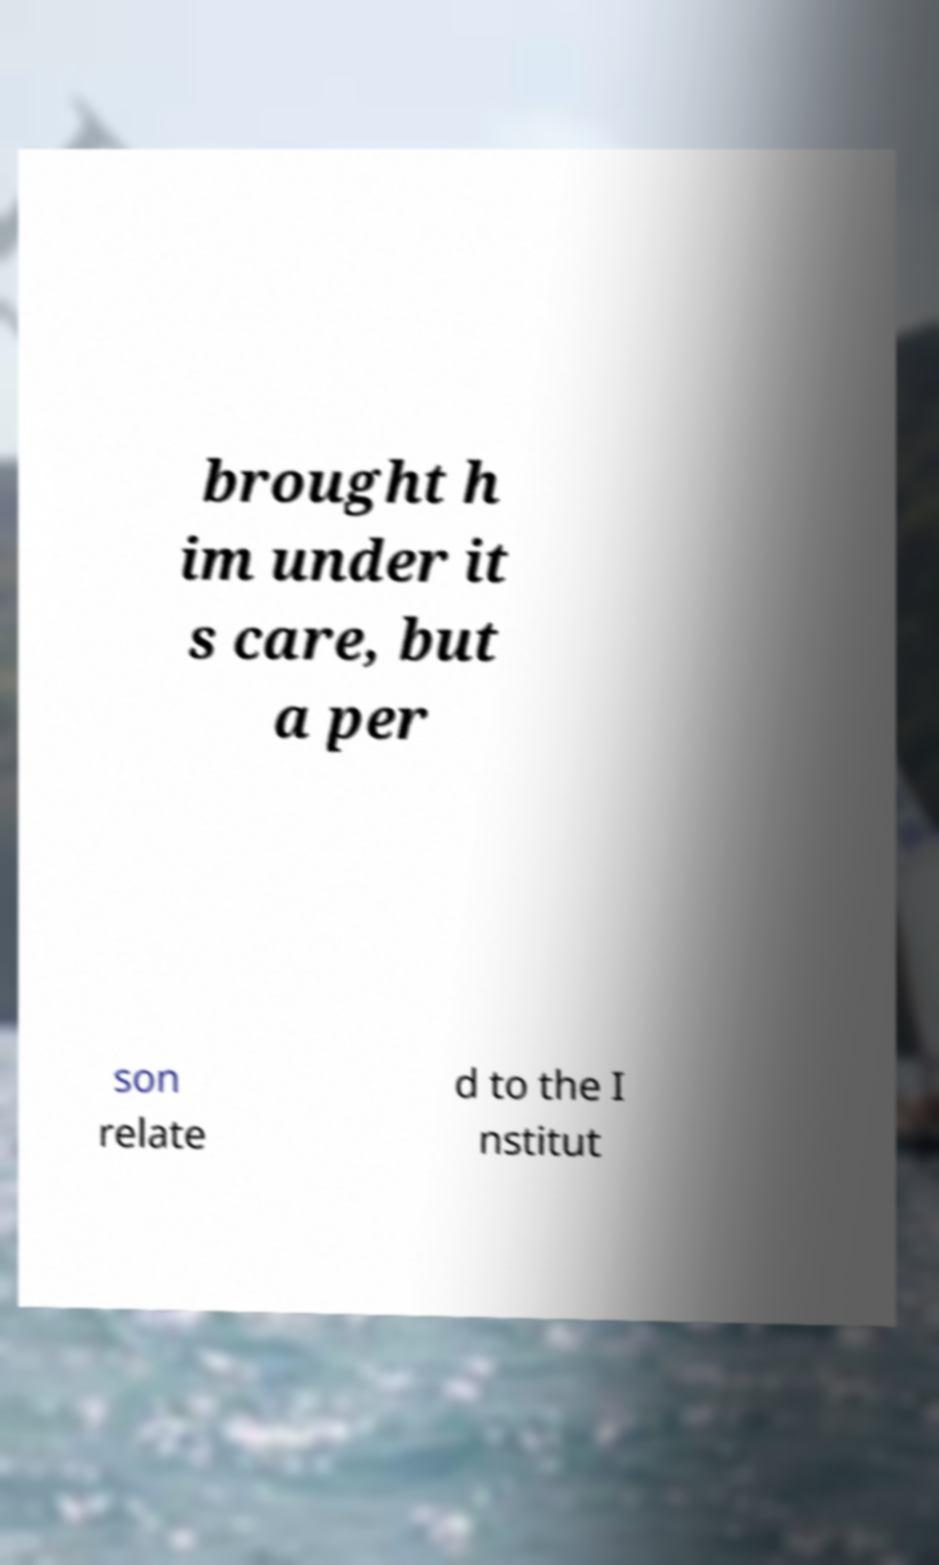Can you accurately transcribe the text from the provided image for me? brought h im under it s care, but a per son relate d to the I nstitut 